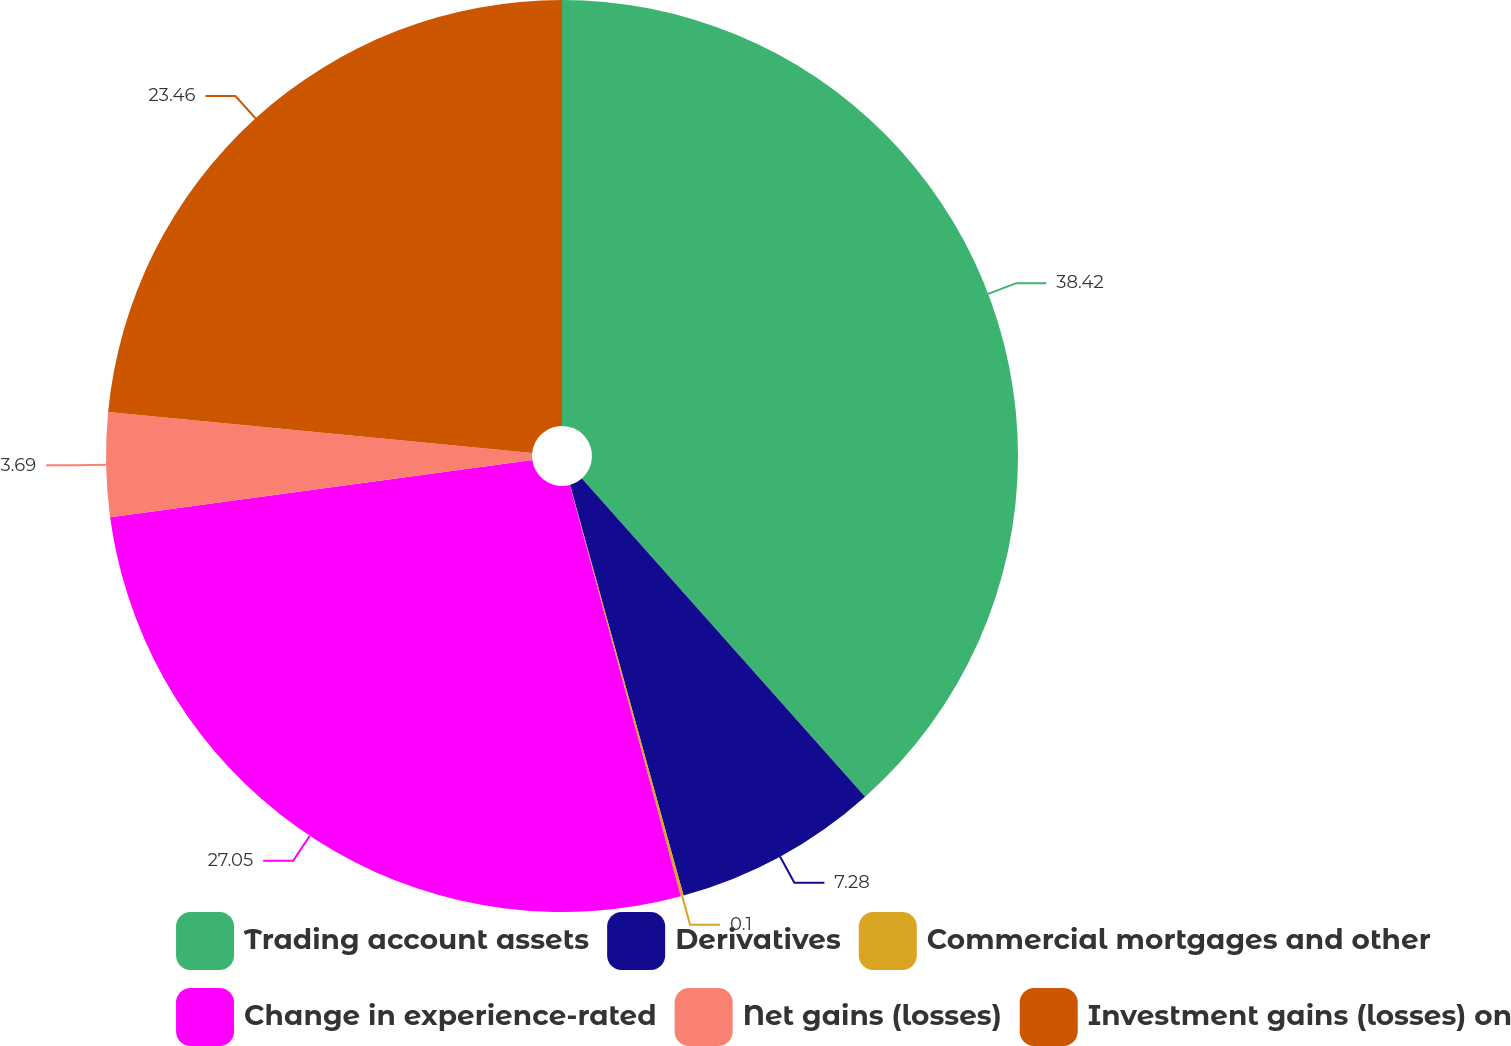Convert chart. <chart><loc_0><loc_0><loc_500><loc_500><pie_chart><fcel>Trading account assets<fcel>Derivatives<fcel>Commercial mortgages and other<fcel>Change in experience-rated<fcel>Net gains (losses)<fcel>Investment gains (losses) on<nl><fcel>38.43%<fcel>7.28%<fcel>0.1%<fcel>27.05%<fcel>3.69%<fcel>23.46%<nl></chart> 